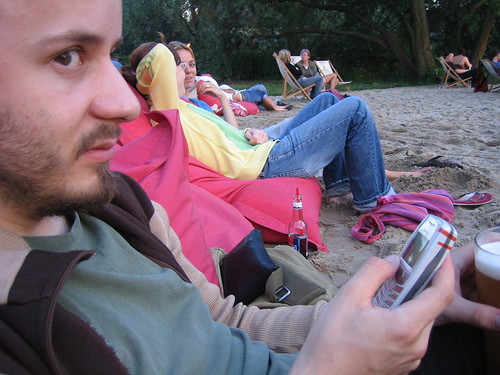<image>Is this a new cell phone? I am not sure if this is a new cell phone. Is this a new cell phone? I don't know if this is a new cell phone. It can be both new and not new. 